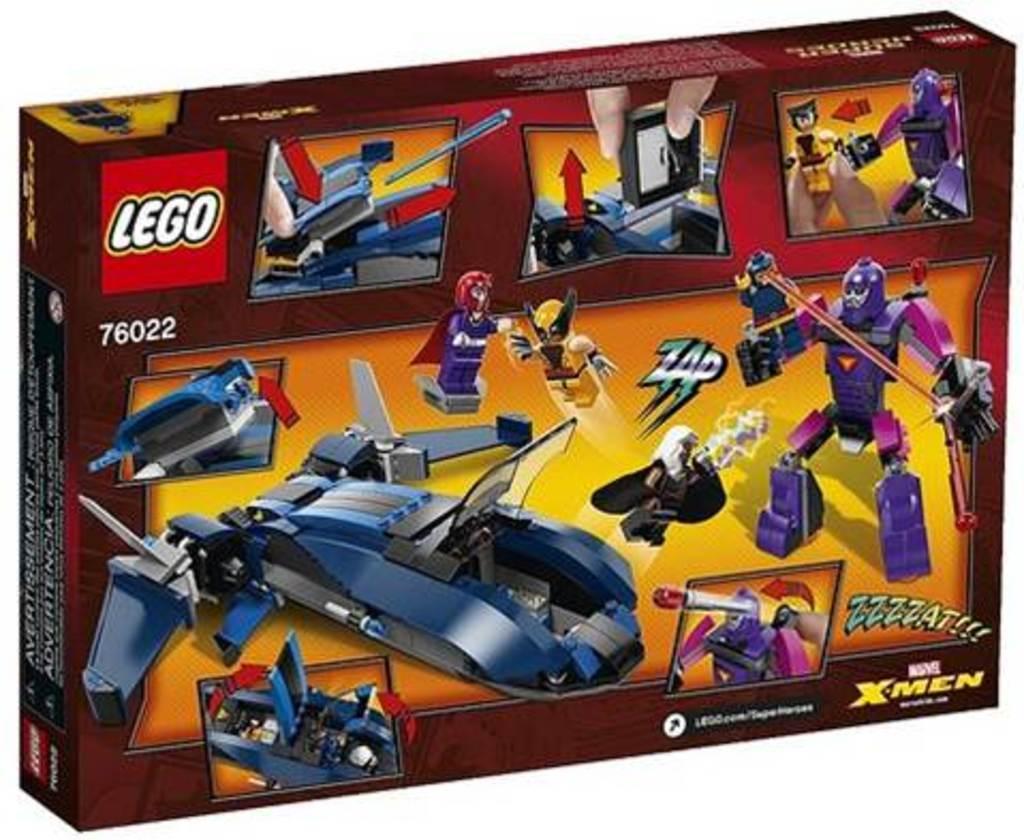In one or two sentences, can you explain what this image depicts? There is a box. On the box something is written. Also there are some robotic toys images on the box. 